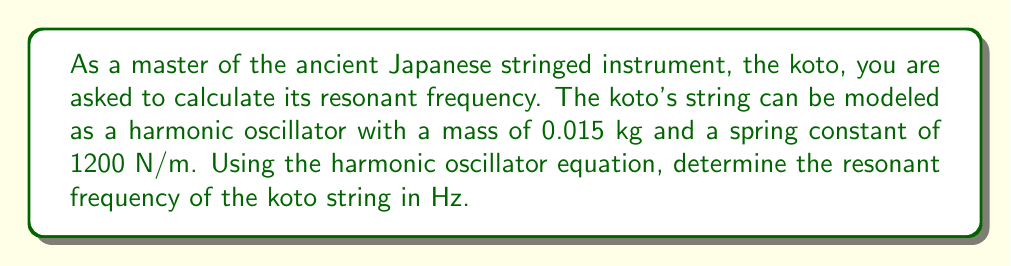Solve this math problem. To solve this problem, we'll use the harmonic oscillator equation for angular frequency and convert it to Hz. The steps are as follows:

1) The equation for angular frequency ($\omega$) of a harmonic oscillator is:

   $$\omega = \sqrt{\frac{k}{m}}$$

   where $k$ is the spring constant and $m$ is the mass.

2) Given:
   $k = 1200$ N/m
   $m = 0.015$ kg

3) Substitute these values into the equation:

   $$\omega = \sqrt{\frac{1200}{0.015}}$$

4) Simplify:
   $$\omega = \sqrt{80000} = 282.8427 \text{ rad/s}$$

5) To convert angular frequency to frequency in Hz, we use the relation:

   $$f = \frac{\omega}{2\pi}$$

6) Substitute our calculated $\omega$:

   $$f = \frac{282.8427}{2\pi} = 45.0295 \text{ Hz}$$

7) Round to two decimal places for the final answer.
Answer: The resonant frequency of the koto string is approximately 45.03 Hz. 